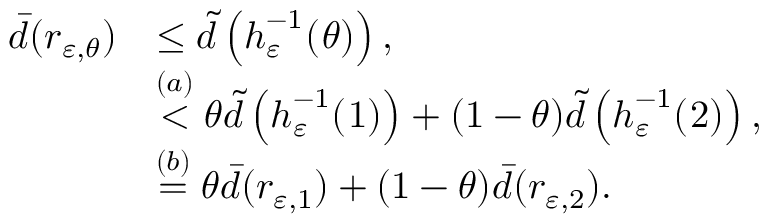<formula> <loc_0><loc_0><loc_500><loc_500>\begin{array} { r l } { \bar { d } ( r _ { \varepsilon , \theta } ) } & { \leq \tilde { d } \left ( h _ { \varepsilon } ^ { - 1 } ( \ r _ { \theta } ) \right ) , } \\ & { \stackrel { ( a ) } { < } \theta \tilde { d } \left ( h _ { \varepsilon } ^ { - 1 } ( \ r _ { 1 } ) \right ) + ( 1 - \theta ) \tilde { d } \left ( h _ { \varepsilon } ^ { - 1 } ( \ r _ { 2 } ) \right ) , } \\ & { \stackrel { ( b ) } { = } \theta \bar { d } ( r _ { \varepsilon , 1 } ) + ( 1 - \theta ) \bar { d } ( r _ { \varepsilon , 2 } ) . } \end{array}</formula> 